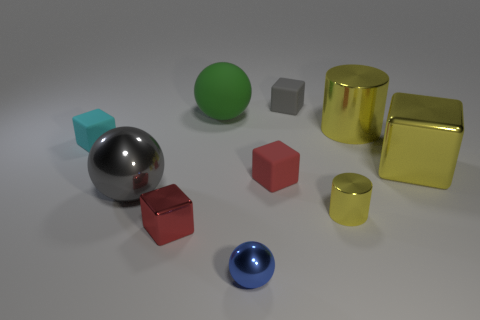There is a tiny thing that is behind the tiny red metallic block and left of the blue object; what material is it made of?
Offer a terse response. Rubber. Is there any other thing that has the same size as the red metal object?
Ensure brevity in your answer.  Yes. Does the big matte thing have the same color as the tiny metallic cube?
Your answer should be compact. No. The tiny metal object that is the same color as the big metal cylinder is what shape?
Your response must be concise. Cylinder. What number of other things have the same shape as the large matte object?
Your response must be concise. 2. What size is the gray thing that is the same material as the cyan block?
Ensure brevity in your answer.  Small. Does the yellow cube have the same size as the red matte cube?
Your answer should be compact. No. Is there a big yellow metallic cylinder?
Provide a short and direct response. Yes. What size is the thing that is the same color as the tiny metallic block?
Keep it short and to the point. Small. There is a yellow shiny thing to the right of the shiny object behind the matte thing left of the tiny red metallic cube; how big is it?
Your answer should be very brief. Large. 